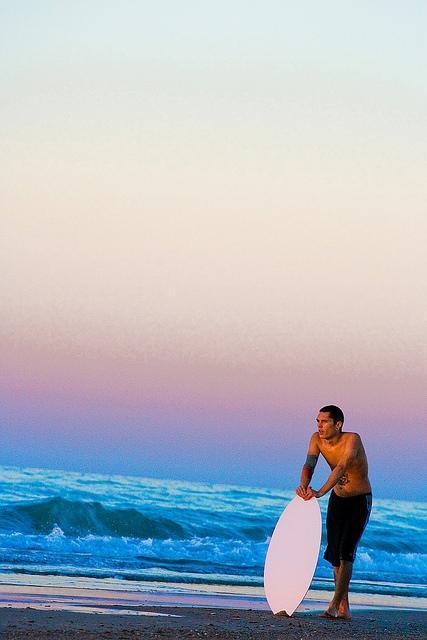How many surfboards are in the photo?
Give a very brief answer. 1. How many zebras are shown in this picture?
Give a very brief answer. 0. 